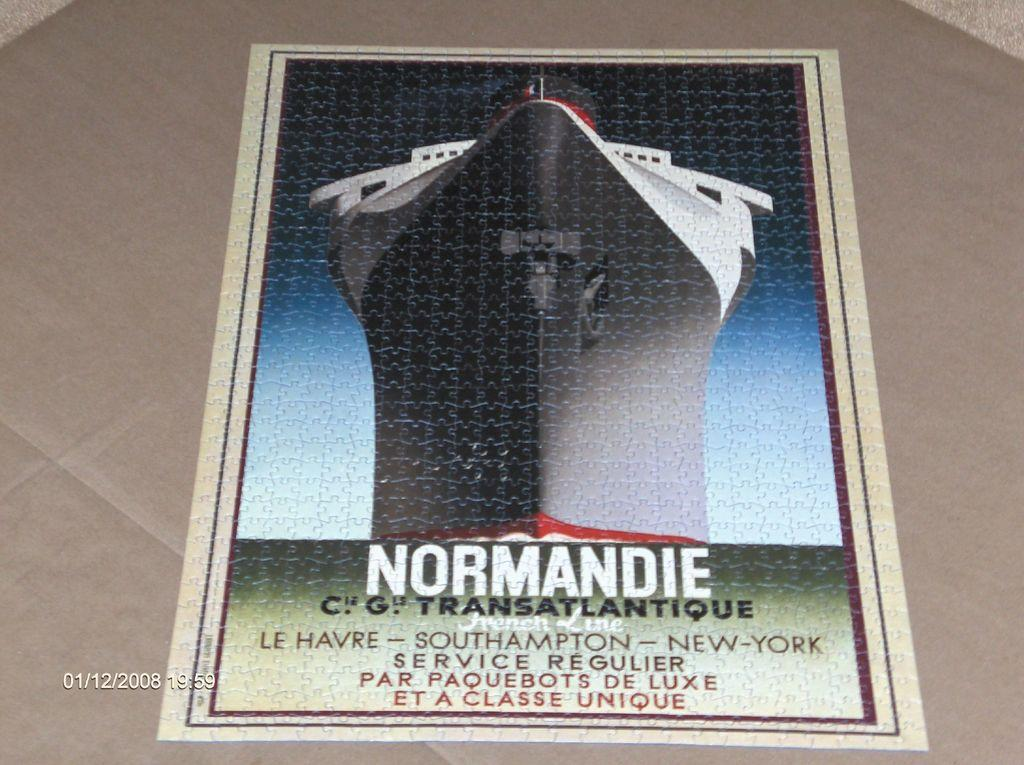<image>
Write a terse but informative summary of the picture. a poster that has Normandie on the front 